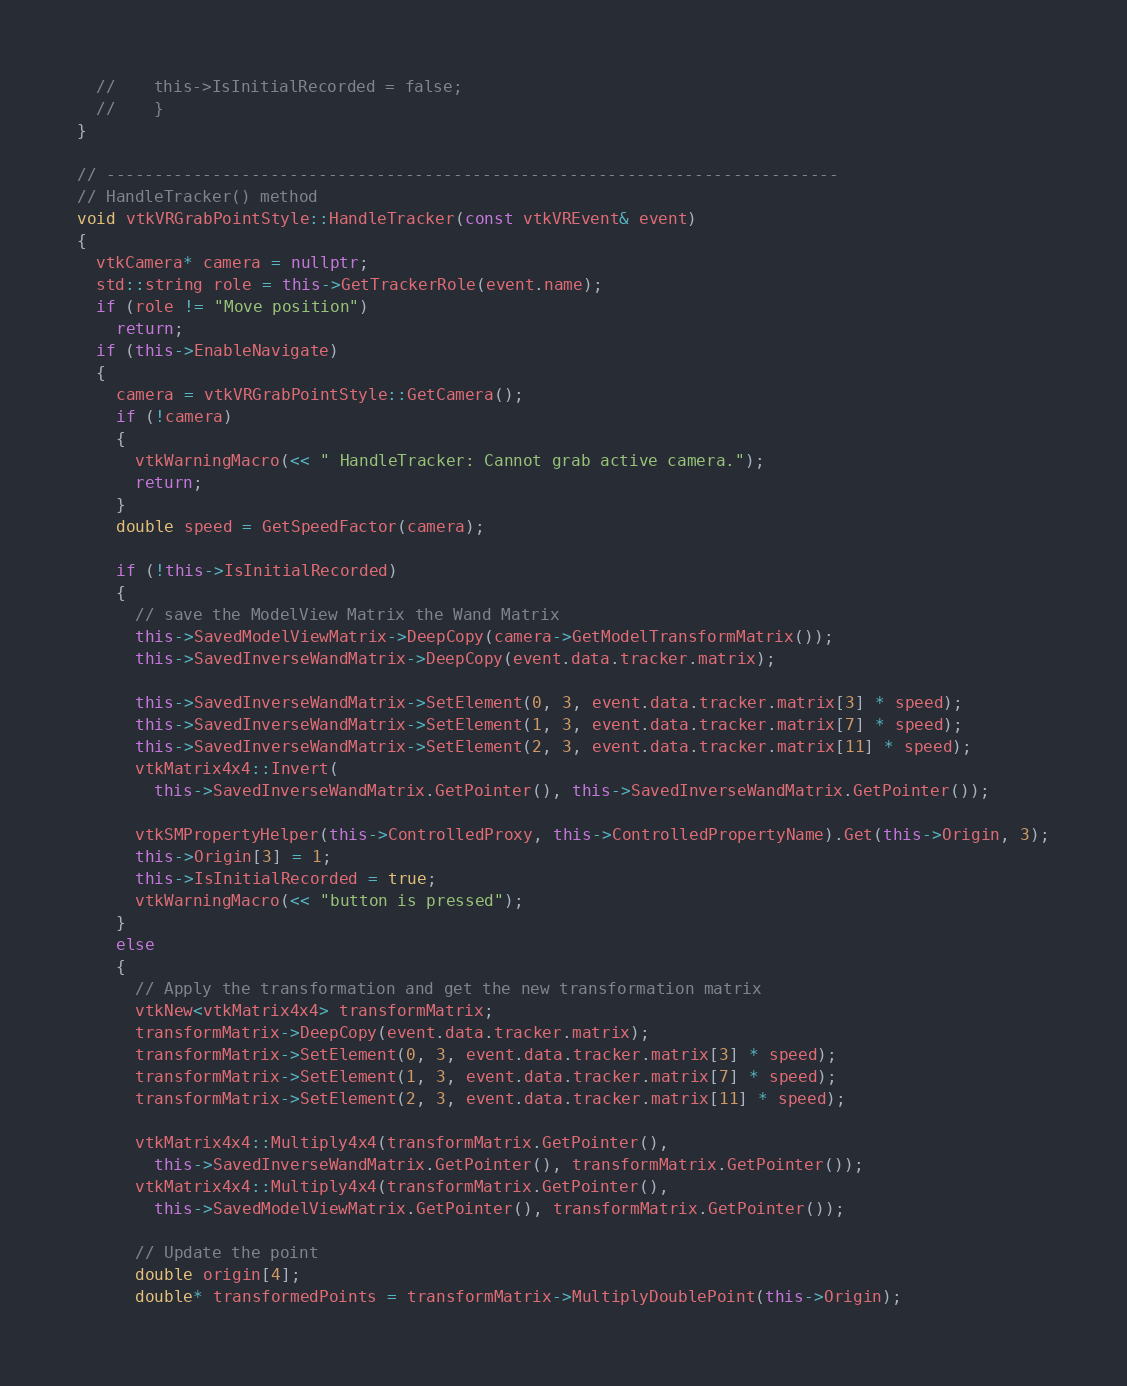Convert code to text. <code><loc_0><loc_0><loc_500><loc_500><_C++_>  //    this->IsInitialRecorded = false;
  //    }
}

// ----------------------------------------------------------------------------
// HandleTracker() method
void vtkVRGrabPointStyle::HandleTracker(const vtkVREvent& event)
{
  vtkCamera* camera = nullptr;
  std::string role = this->GetTrackerRole(event.name);
  if (role != "Move position")
    return;
  if (this->EnableNavigate)
  {
    camera = vtkVRGrabPointStyle::GetCamera();
    if (!camera)
    {
      vtkWarningMacro(<< " HandleTracker: Cannot grab active camera.");
      return;
    }
    double speed = GetSpeedFactor(camera);

    if (!this->IsInitialRecorded)
    {
      // save the ModelView Matrix the Wand Matrix
      this->SavedModelViewMatrix->DeepCopy(camera->GetModelTransformMatrix());
      this->SavedInverseWandMatrix->DeepCopy(event.data.tracker.matrix);

      this->SavedInverseWandMatrix->SetElement(0, 3, event.data.tracker.matrix[3] * speed);
      this->SavedInverseWandMatrix->SetElement(1, 3, event.data.tracker.matrix[7] * speed);
      this->SavedInverseWandMatrix->SetElement(2, 3, event.data.tracker.matrix[11] * speed);
      vtkMatrix4x4::Invert(
        this->SavedInverseWandMatrix.GetPointer(), this->SavedInverseWandMatrix.GetPointer());

      vtkSMPropertyHelper(this->ControlledProxy, this->ControlledPropertyName).Get(this->Origin, 3);
      this->Origin[3] = 1;
      this->IsInitialRecorded = true;
      vtkWarningMacro(<< "button is pressed");
    }
    else
    {
      // Apply the transformation and get the new transformation matrix
      vtkNew<vtkMatrix4x4> transformMatrix;
      transformMatrix->DeepCopy(event.data.tracker.matrix);
      transformMatrix->SetElement(0, 3, event.data.tracker.matrix[3] * speed);
      transformMatrix->SetElement(1, 3, event.data.tracker.matrix[7] * speed);
      transformMatrix->SetElement(2, 3, event.data.tracker.matrix[11] * speed);

      vtkMatrix4x4::Multiply4x4(transformMatrix.GetPointer(),
        this->SavedInverseWandMatrix.GetPointer(), transformMatrix.GetPointer());
      vtkMatrix4x4::Multiply4x4(transformMatrix.GetPointer(),
        this->SavedModelViewMatrix.GetPointer(), transformMatrix.GetPointer());

      // Update the point
      double origin[4];
      double* transformedPoints = transformMatrix->MultiplyDoublePoint(this->Origin);</code> 